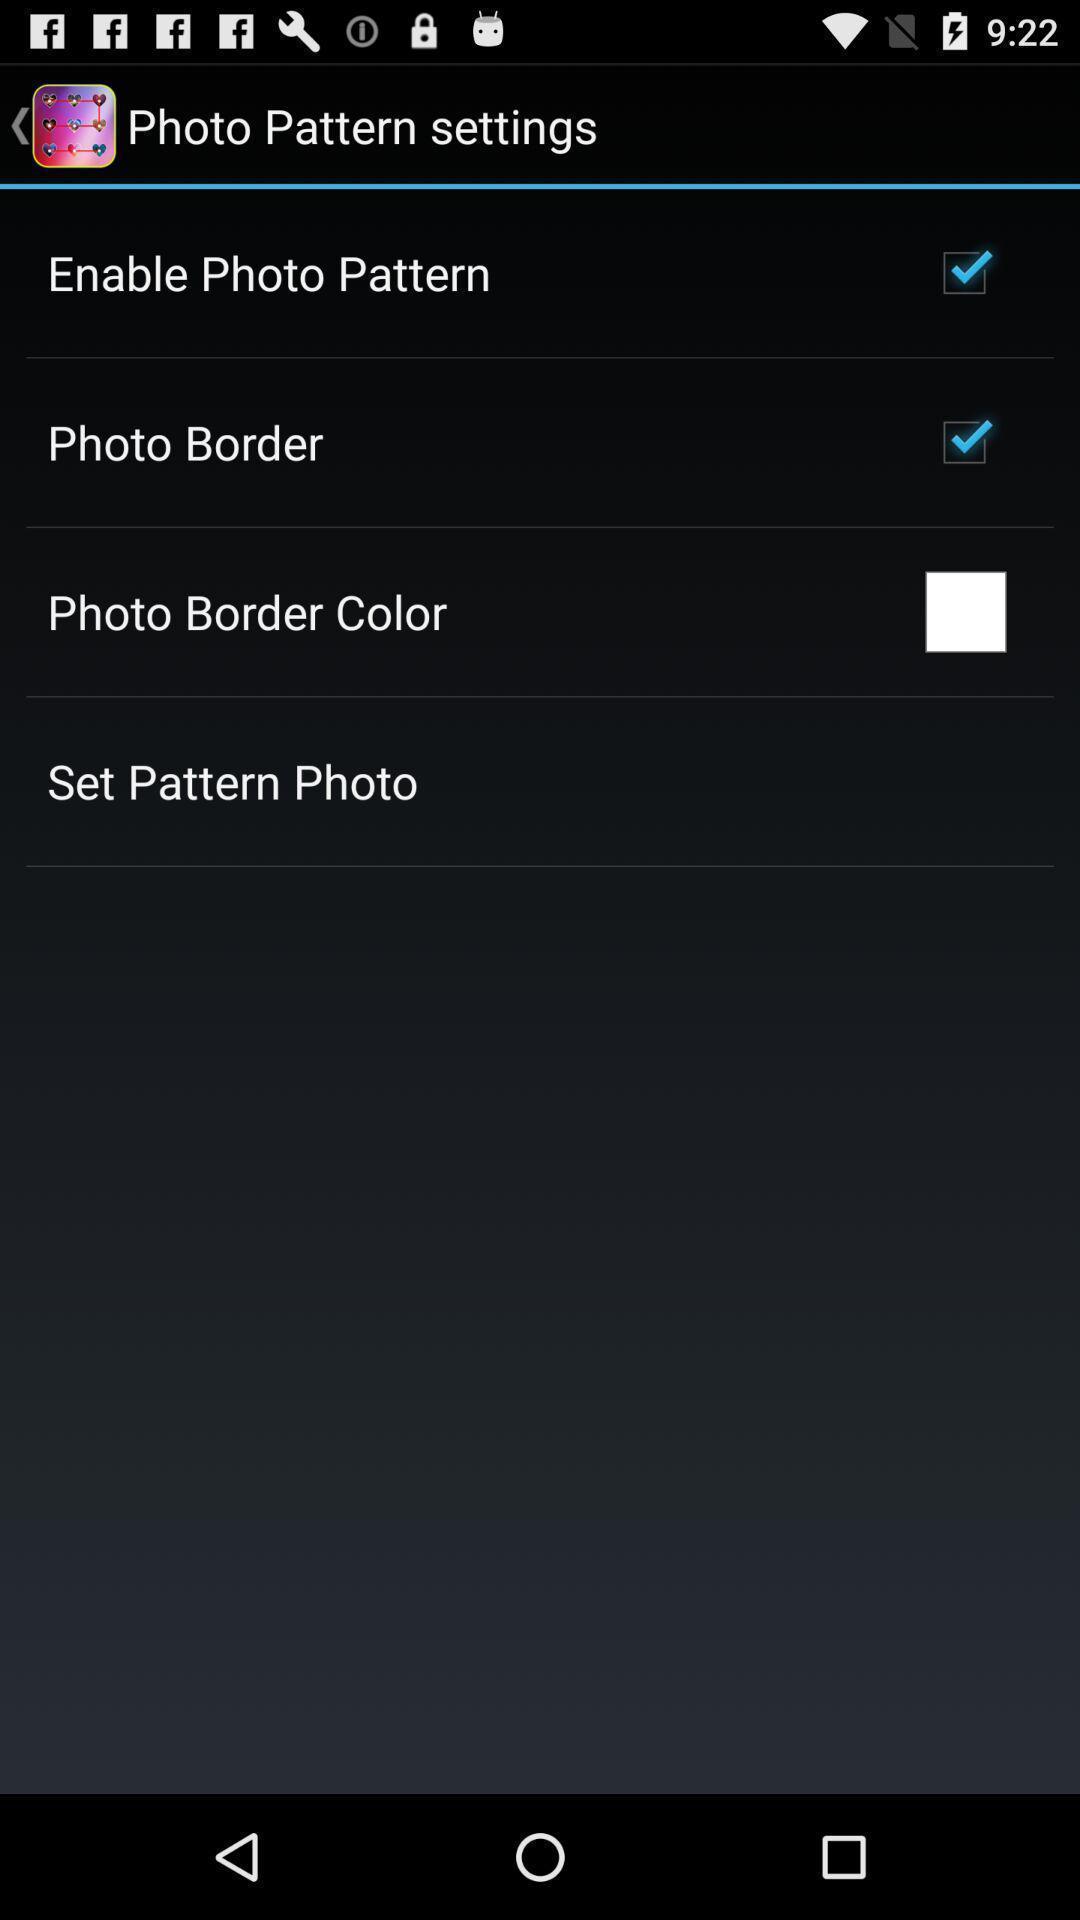Provide a detailed account of this screenshot. Photo settings page. 